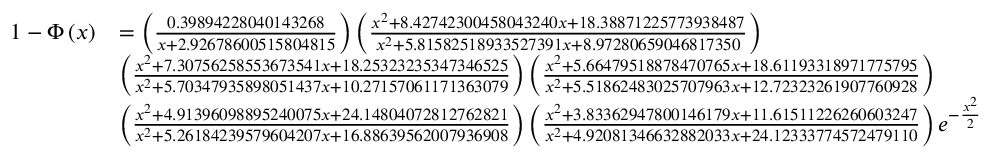<formula> <loc_0><loc_0><loc_500><loc_500>{ \begin{array} { r l } { 1 - \Phi \left ( x \right ) } & { = \left ( { \frac { 0 . 3 9 8 9 4 2 2 8 0 4 0 1 4 3 2 6 8 } { x + 2 . 9 2 6 7 8 6 0 0 5 1 5 8 0 4 8 1 5 } } \right ) \left ( { \frac { x ^ { 2 } + 8 . 4 2 7 4 2 3 0 0 4 5 8 0 4 3 2 4 0 x + 1 8 . 3 8 8 7 1 2 2 5 7 7 3 9 3 8 4 8 7 } { x ^ { 2 } + 5 . 8 1 5 8 2 5 1 8 9 3 3 5 2 7 3 9 1 x + 8 . 9 7 2 8 0 6 5 9 0 4 6 8 1 7 3 5 0 } } \right ) } \\ & { \left ( { \frac { x ^ { 2 } + 7 . 3 0 7 5 6 2 5 8 5 5 3 6 7 3 5 4 1 x + 1 8 . 2 5 3 2 3 2 3 5 3 4 7 3 4 6 5 2 5 } { x ^ { 2 } + 5 . 7 0 3 4 7 9 3 5 8 9 8 0 5 1 4 3 7 x + 1 0 . 2 7 1 5 7 0 6 1 1 7 1 3 6 3 0 7 9 } } \right ) \left ( { \frac { x ^ { 2 } + 5 . 6 6 4 7 9 5 1 8 8 7 8 4 7 0 7 6 5 x + 1 8 . 6 1 1 9 3 3 1 8 9 7 1 7 7 5 7 9 5 } { x ^ { 2 } + 5 . 5 1 8 6 2 4 8 3 0 2 5 7 0 7 9 6 3 x + 1 2 . 7 2 3 2 3 2 6 1 9 0 7 7 6 0 9 2 8 } } \right ) } \\ & { \left ( { \frac { x ^ { 2 } + 4 . 9 1 3 9 6 0 9 8 8 9 5 2 4 0 0 7 5 x + 2 4 . 1 4 8 0 4 0 7 2 8 1 2 7 6 2 8 2 1 } { x ^ { 2 } + 5 . 2 6 1 8 4 2 3 9 5 7 9 6 0 4 2 0 7 x + 1 6 . 8 8 6 3 9 5 6 2 0 0 7 9 3 6 9 0 8 } } \right ) \left ( { \frac { x ^ { 2 } + 3 . 8 3 3 6 2 9 4 7 8 0 0 1 4 6 1 7 9 x + 1 1 . 6 1 5 1 1 2 2 6 2 6 0 6 0 3 2 4 7 } { x ^ { 2 } + 4 . 9 2 0 8 1 3 4 6 6 3 2 8 8 2 0 3 3 x + 2 4 . 1 2 3 3 3 7 7 4 5 7 2 4 7 9 1 1 0 } } \right ) e ^ { - { \frac { x ^ { 2 } } { 2 } } } } \end{array} }</formula> 